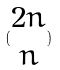<formula> <loc_0><loc_0><loc_500><loc_500>( \begin{matrix} 2 n \\ n \end{matrix} )</formula> 